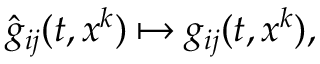Convert formula to latex. <formula><loc_0><loc_0><loc_500><loc_500>{ \hat { g } } _ { i j } ( t , x ^ { k } ) \mapsto g _ { i j } ( t , x ^ { k } ) ,</formula> 